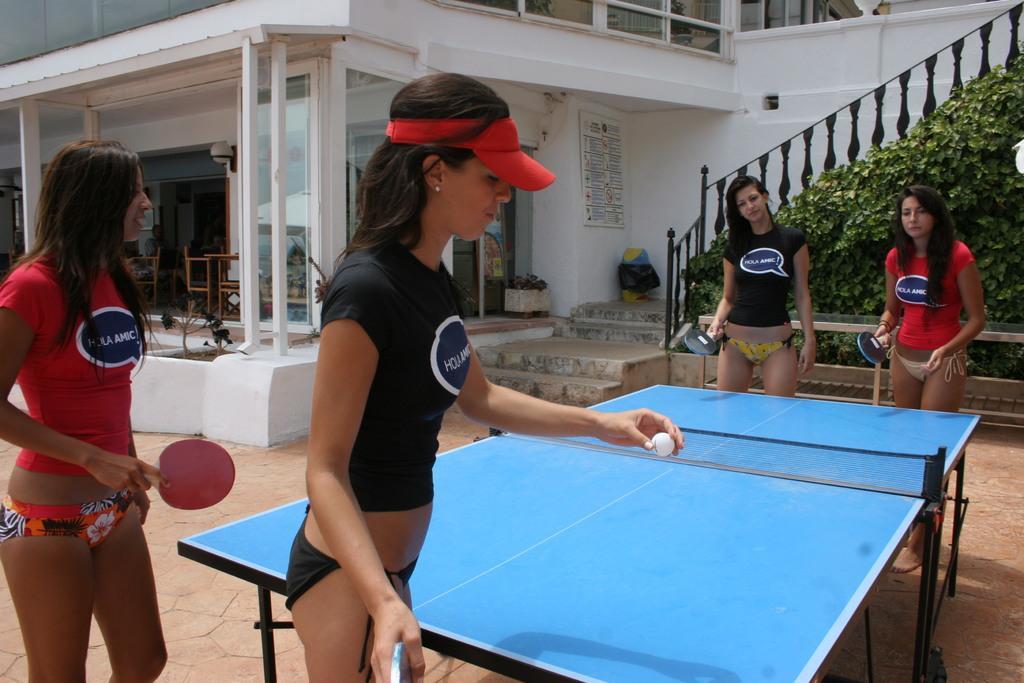Please provide a concise description of this image. It is a open space in front of the house there are total four women playing table tennis,behind them there is a table and also some plants,to the left side there are stairs,in the background there is a house which is of white color. 